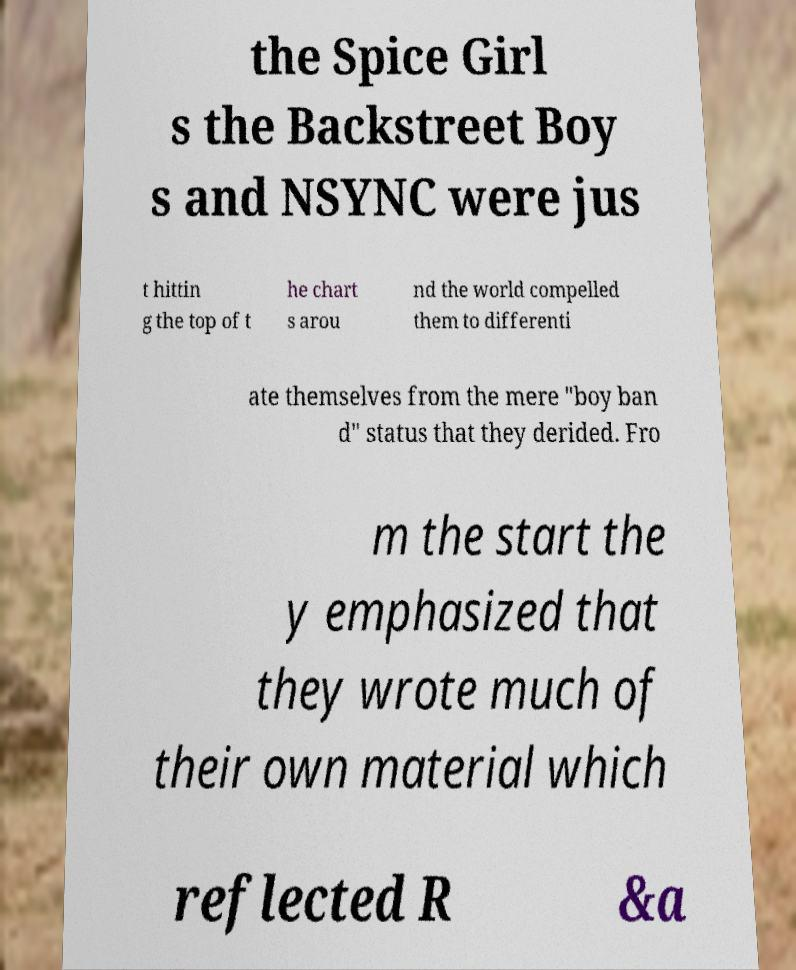Could you assist in decoding the text presented in this image and type it out clearly? the Spice Girl s the Backstreet Boy s and NSYNC were jus t hittin g the top of t he chart s arou nd the world compelled them to differenti ate themselves from the mere "boy ban d" status that they derided. Fro m the start the y emphasized that they wrote much of their own material which reflected R &a 